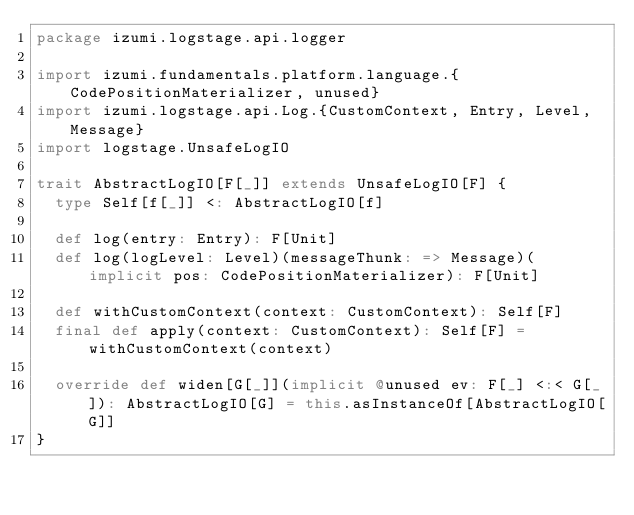<code> <loc_0><loc_0><loc_500><loc_500><_Scala_>package izumi.logstage.api.logger

import izumi.fundamentals.platform.language.{CodePositionMaterializer, unused}
import izumi.logstage.api.Log.{CustomContext, Entry, Level, Message}
import logstage.UnsafeLogIO

trait AbstractLogIO[F[_]] extends UnsafeLogIO[F] {
  type Self[f[_]] <: AbstractLogIO[f]

  def log(entry: Entry): F[Unit]
  def log(logLevel: Level)(messageThunk: => Message)(implicit pos: CodePositionMaterializer): F[Unit]

  def withCustomContext(context: CustomContext): Self[F]
  final def apply(context: CustomContext): Self[F] = withCustomContext(context)

  override def widen[G[_]](implicit @unused ev: F[_] <:< G[_]): AbstractLogIO[G] = this.asInstanceOf[AbstractLogIO[G]]
}
</code> 